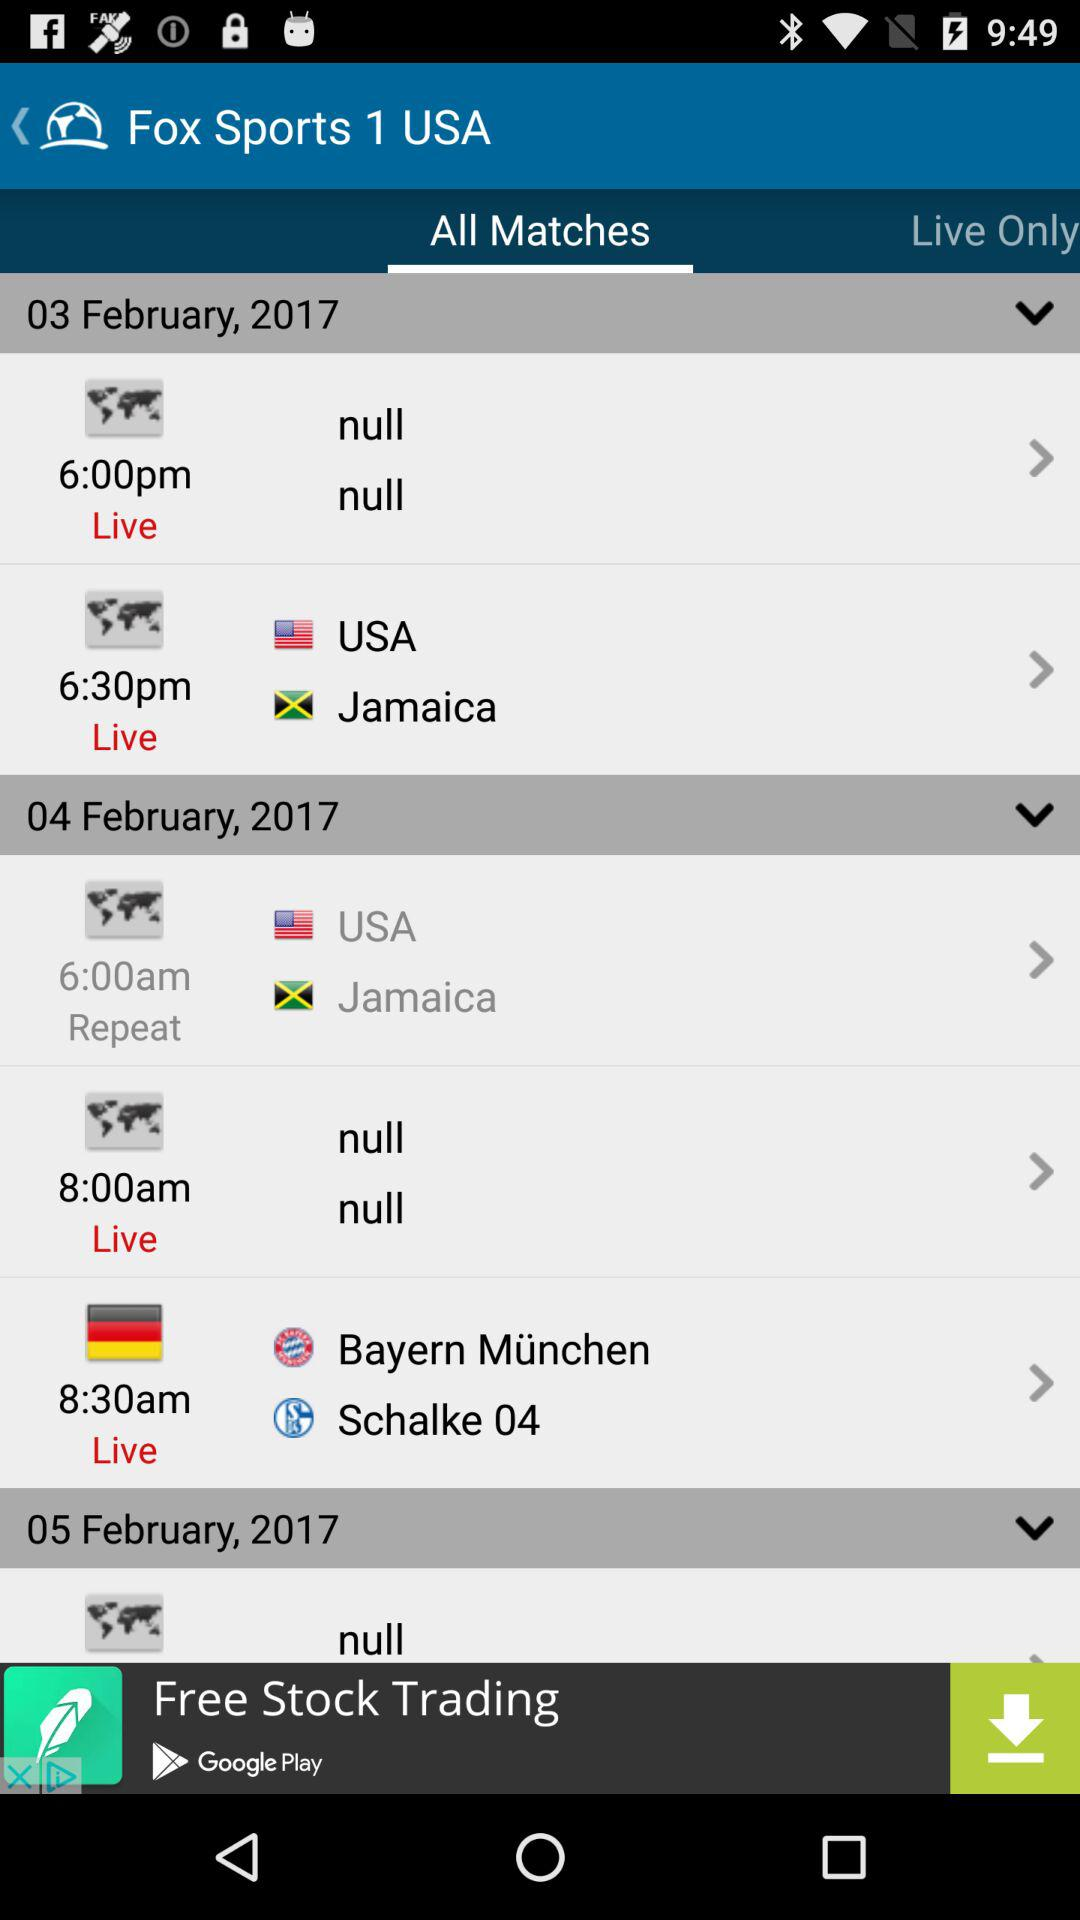At what time is the live match between "USA" and "Jamaica" scheduled? The live match between "USA" and "Jamaica" is scheduled at 6:30 p.m. 